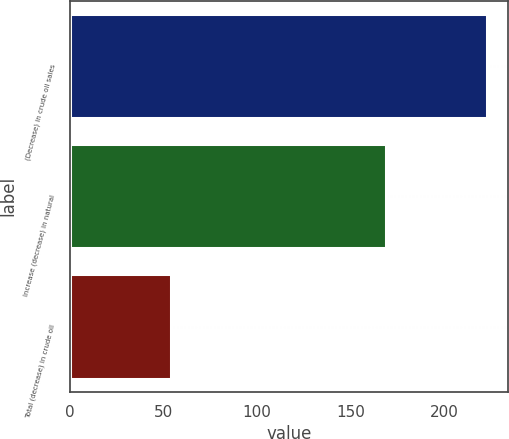<chart> <loc_0><loc_0><loc_500><loc_500><bar_chart><fcel>(Decrease) in crude oil sales<fcel>Increase (decrease) in natural<fcel>Total (decrease) in crude oil<nl><fcel>223<fcel>169<fcel>54<nl></chart> 